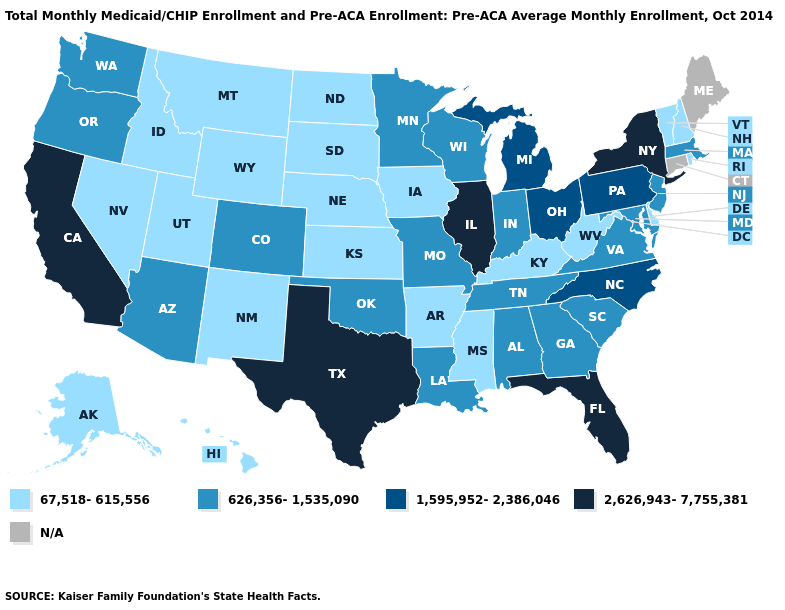Does New Jersey have the highest value in the Northeast?
Give a very brief answer. No. What is the lowest value in the MidWest?
Write a very short answer. 67,518-615,556. Among the states that border Oregon , does Nevada have the lowest value?
Quick response, please. Yes. Name the states that have a value in the range 67,518-615,556?
Keep it brief. Alaska, Arkansas, Delaware, Hawaii, Idaho, Iowa, Kansas, Kentucky, Mississippi, Montana, Nebraska, Nevada, New Hampshire, New Mexico, North Dakota, Rhode Island, South Dakota, Utah, Vermont, West Virginia, Wyoming. Among the states that border Oregon , does California have the highest value?
Give a very brief answer. Yes. Name the states that have a value in the range 1,595,952-2,386,046?
Quick response, please. Michigan, North Carolina, Ohio, Pennsylvania. Name the states that have a value in the range 626,356-1,535,090?
Answer briefly. Alabama, Arizona, Colorado, Georgia, Indiana, Louisiana, Maryland, Massachusetts, Minnesota, Missouri, New Jersey, Oklahoma, Oregon, South Carolina, Tennessee, Virginia, Washington, Wisconsin. What is the value of Nevada?
Answer briefly. 67,518-615,556. What is the highest value in the South ?
Keep it brief. 2,626,943-7,755,381. What is the highest value in the USA?
Write a very short answer. 2,626,943-7,755,381. What is the value of Minnesota?
Give a very brief answer. 626,356-1,535,090. Name the states that have a value in the range 67,518-615,556?
Short answer required. Alaska, Arkansas, Delaware, Hawaii, Idaho, Iowa, Kansas, Kentucky, Mississippi, Montana, Nebraska, Nevada, New Hampshire, New Mexico, North Dakota, Rhode Island, South Dakota, Utah, Vermont, West Virginia, Wyoming. Name the states that have a value in the range N/A?
Concise answer only. Connecticut, Maine. What is the value of Oklahoma?
Write a very short answer. 626,356-1,535,090. 